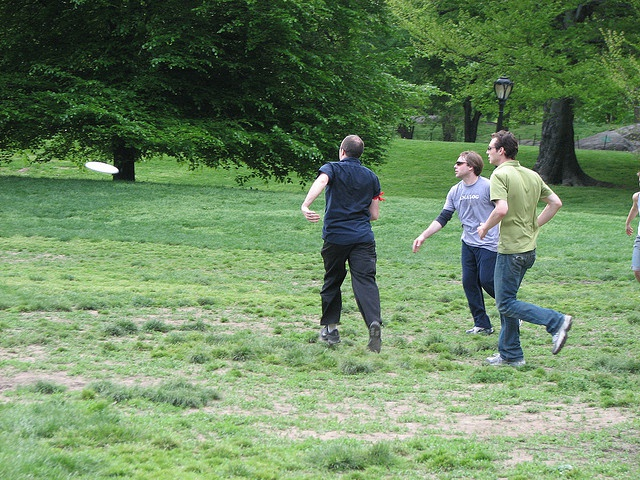Describe the objects in this image and their specific colors. I can see people in black, darkgray, blue, olive, and ivory tones, people in black, navy, gray, and darkblue tones, people in black, navy, darkgray, and lavender tones, people in black, darkgray, gray, and white tones, and frisbee in black, white, gray, and darkgray tones in this image. 